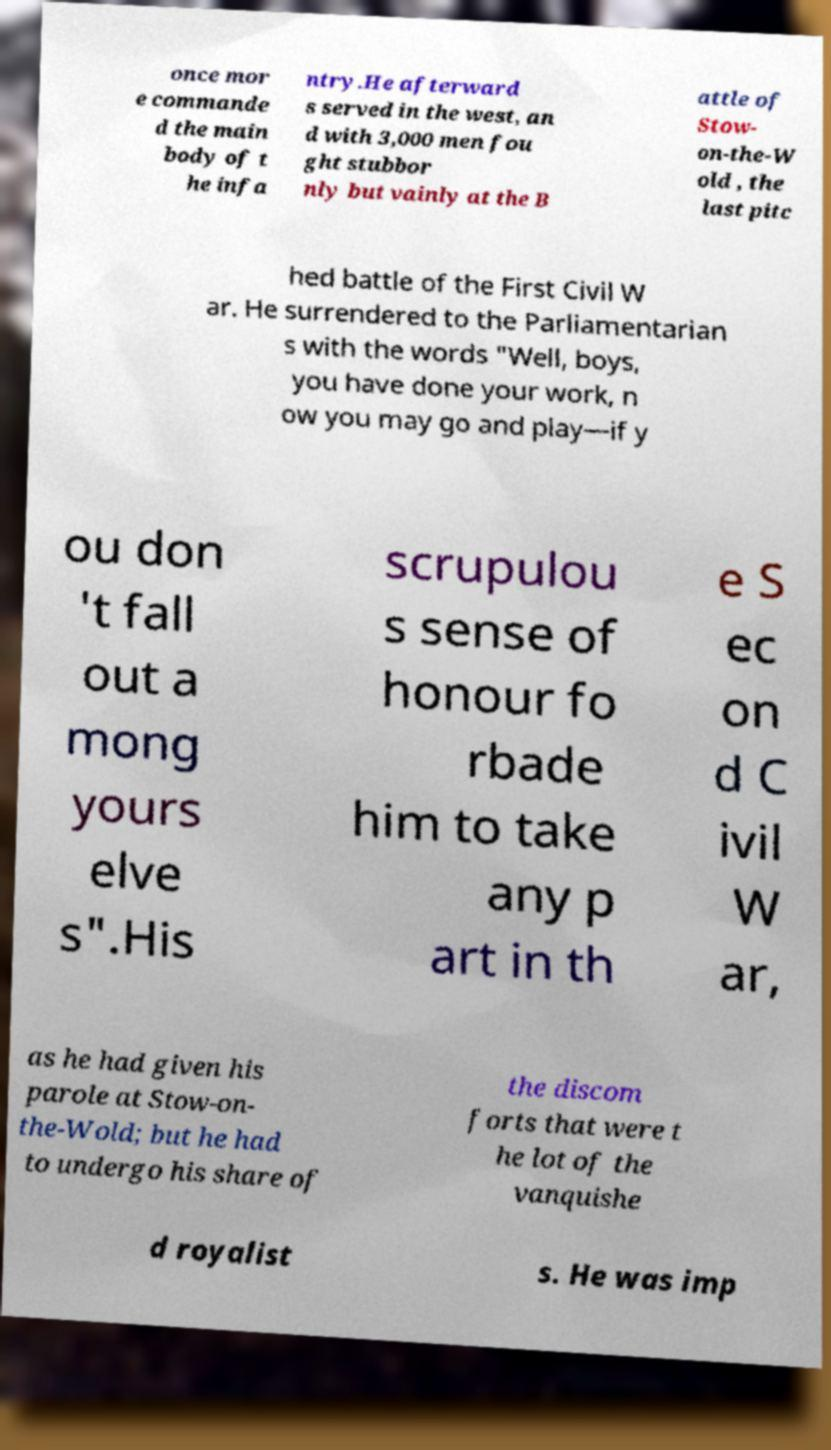Can you accurately transcribe the text from the provided image for me? once mor e commande d the main body of t he infa ntry.He afterward s served in the west, an d with 3,000 men fou ght stubbor nly but vainly at the B attle of Stow- on-the-W old , the last pitc hed battle of the First Civil W ar. He surrendered to the Parliamentarian s with the words "Well, boys, you have done your work, n ow you may go and play—if y ou don 't fall out a mong yours elve s".His scrupulou s sense of honour fo rbade him to take any p art in th e S ec on d C ivil W ar, as he had given his parole at Stow-on- the-Wold; but he had to undergo his share of the discom forts that were t he lot of the vanquishe d royalist s. He was imp 